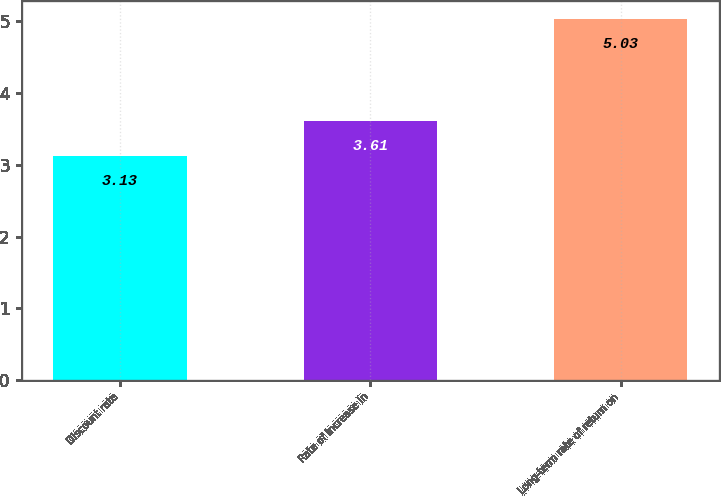Convert chart to OTSL. <chart><loc_0><loc_0><loc_500><loc_500><bar_chart><fcel>Discount rate<fcel>Rate of increase in<fcel>Long-term rate of return on<nl><fcel>3.13<fcel>3.61<fcel>5.03<nl></chart> 